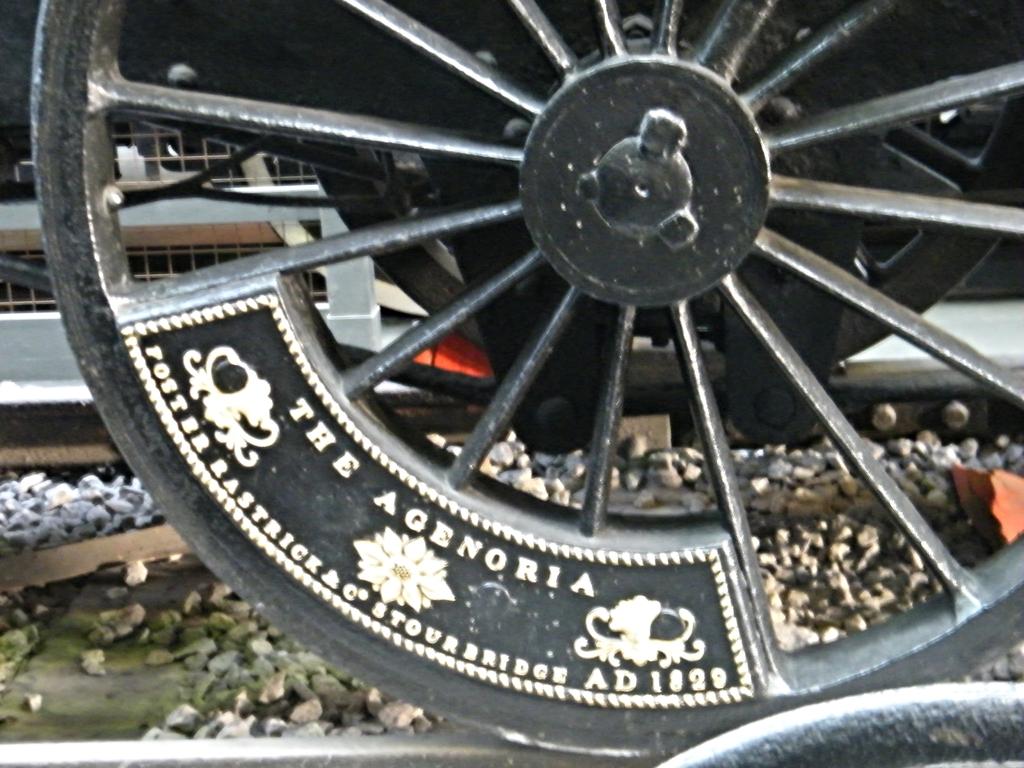What are the two words printed on the top of this plaque, on this wheel?
Keep it short and to the point. The agenoria. What year is mentioned on the wheel of this vehicle?
Offer a very short reply. 1829. 